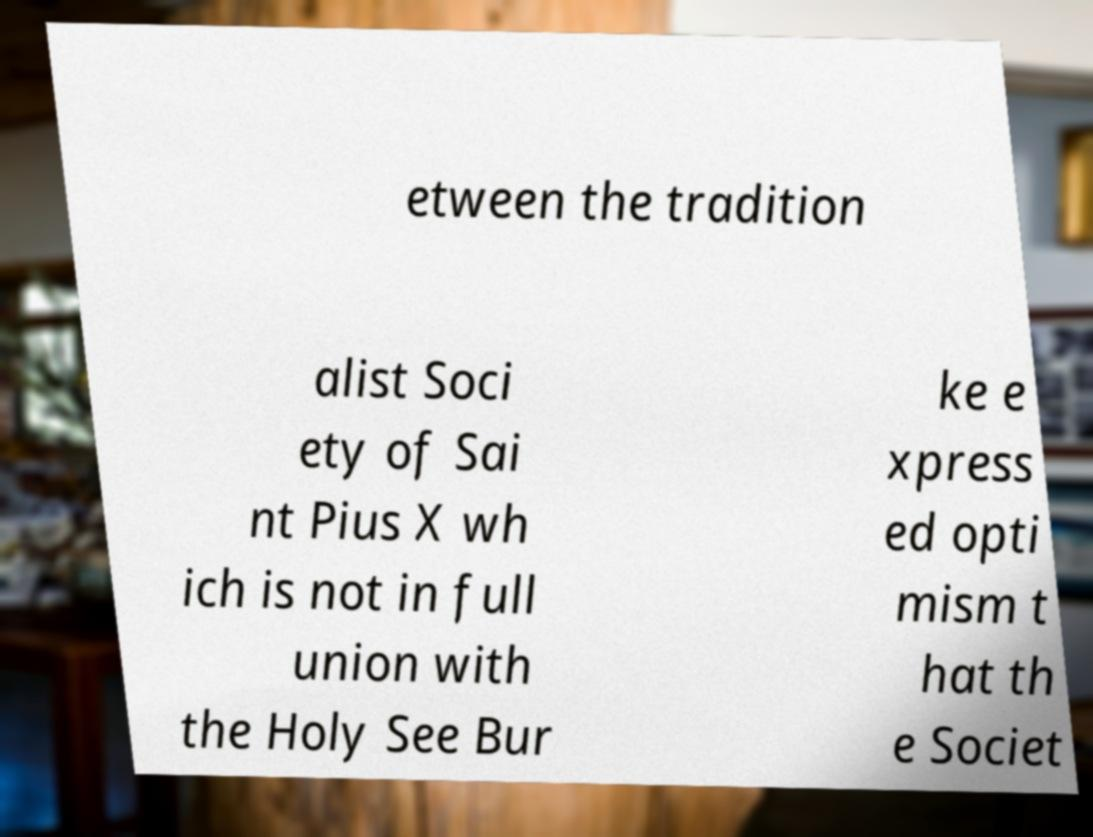I need the written content from this picture converted into text. Can you do that? etween the tradition alist Soci ety of Sai nt Pius X wh ich is not in full union with the Holy See Bur ke e xpress ed opti mism t hat th e Societ 